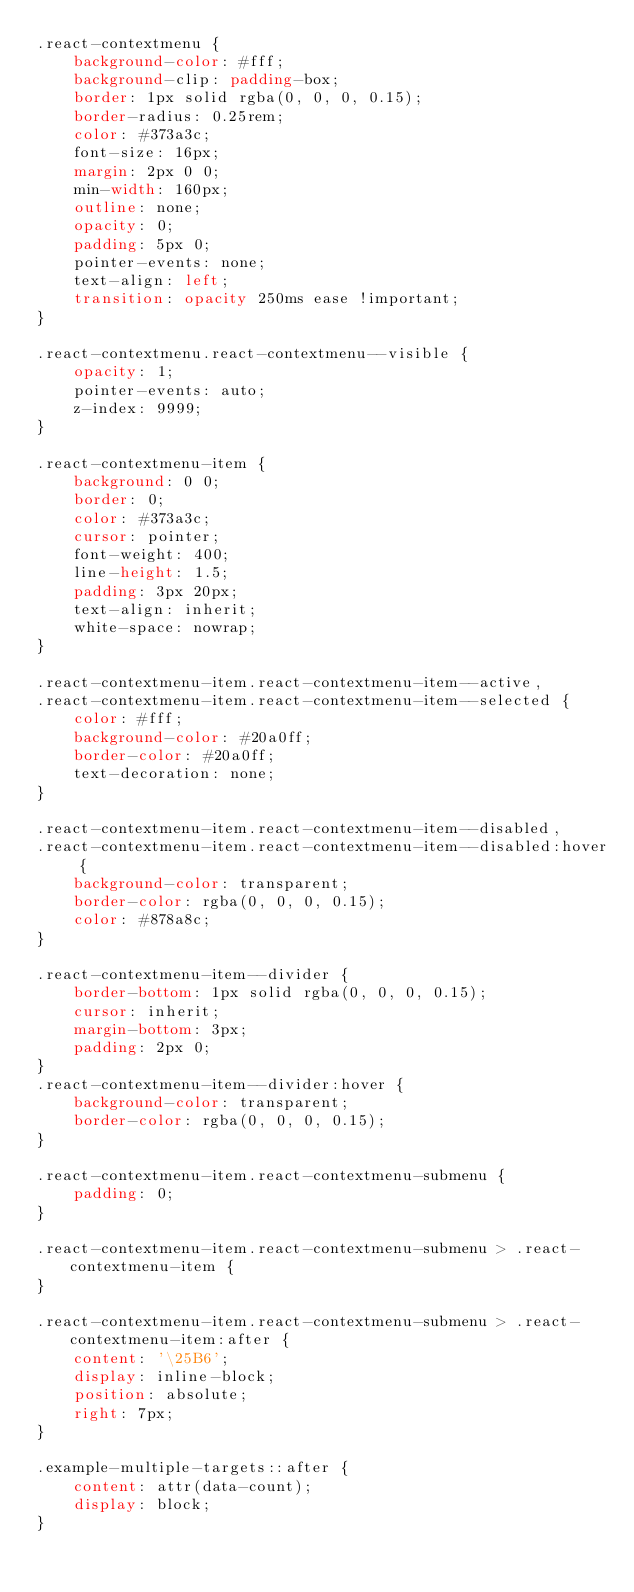Convert code to text. <code><loc_0><loc_0><loc_500><loc_500><_CSS_>.react-contextmenu {
    background-color: #fff;
    background-clip: padding-box;
    border: 1px solid rgba(0, 0, 0, 0.15);
    border-radius: 0.25rem;
    color: #373a3c;
    font-size: 16px;
    margin: 2px 0 0;
    min-width: 160px;
    outline: none;
    opacity: 0;
    padding: 5px 0;
    pointer-events: none;
    text-align: left;
    transition: opacity 250ms ease !important;
}

.react-contextmenu.react-contextmenu--visible {
    opacity: 1;
    pointer-events: auto;
    z-index: 9999;
}

.react-contextmenu-item {
    background: 0 0;
    border: 0;
    color: #373a3c;
    cursor: pointer;
    font-weight: 400;
    line-height: 1.5;
    padding: 3px 20px;
    text-align: inherit;
    white-space: nowrap;
}

.react-contextmenu-item.react-contextmenu-item--active,
.react-contextmenu-item.react-contextmenu-item--selected {
    color: #fff;
    background-color: #20a0ff;
    border-color: #20a0ff;
    text-decoration: none;
}

.react-contextmenu-item.react-contextmenu-item--disabled,
.react-contextmenu-item.react-contextmenu-item--disabled:hover {
    background-color: transparent;
    border-color: rgba(0, 0, 0, 0.15);
    color: #878a8c;
}

.react-contextmenu-item--divider {
    border-bottom: 1px solid rgba(0, 0, 0, 0.15);
    cursor: inherit;
    margin-bottom: 3px;
    padding: 2px 0;
}
.react-contextmenu-item--divider:hover {
    background-color: transparent;
    border-color: rgba(0, 0, 0, 0.15);
}

.react-contextmenu-item.react-contextmenu-submenu {
    padding: 0;
}

.react-contextmenu-item.react-contextmenu-submenu > .react-contextmenu-item {
}

.react-contextmenu-item.react-contextmenu-submenu > .react-contextmenu-item:after {
    content: '\25B6';
    display: inline-block;
    position: absolute;
    right: 7px;
}

.example-multiple-targets::after {
    content: attr(data-count);
    display: block;
}
</code> 